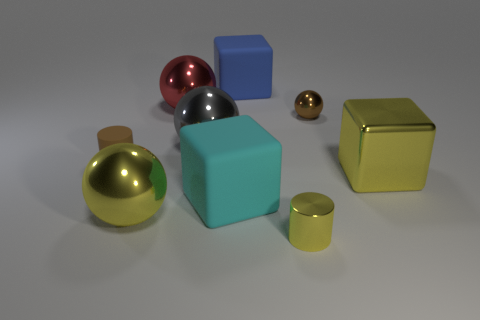What is the shape of the large metallic object that is to the left of the tiny shiny cylinder and in front of the large gray shiny thing?
Offer a terse response. Sphere. Is there another yellow block made of the same material as the big yellow cube?
Give a very brief answer. No. There is another object that is the same color as the tiny rubber thing; what is it made of?
Offer a very short reply. Metal. Is the material of the brown object left of the small yellow shiny object the same as the tiny brown object that is right of the cyan rubber thing?
Your response must be concise. No. Is the number of yellow blocks greater than the number of small objects?
Make the answer very short. No. What color is the tiny cylinder on the right side of the tiny brown object that is to the left of the blue rubber block to the right of the rubber cylinder?
Your answer should be very brief. Yellow. There is a small shiny object that is in front of the large yellow cube; does it have the same color as the block to the right of the blue cube?
Keep it short and to the point. Yes. What number of blue cubes are to the right of the large matte object that is in front of the brown metallic ball?
Make the answer very short. 1. Is there a small cyan rubber block?
Make the answer very short. No. What number of other objects are there of the same color as the small rubber object?
Provide a short and direct response. 1. 